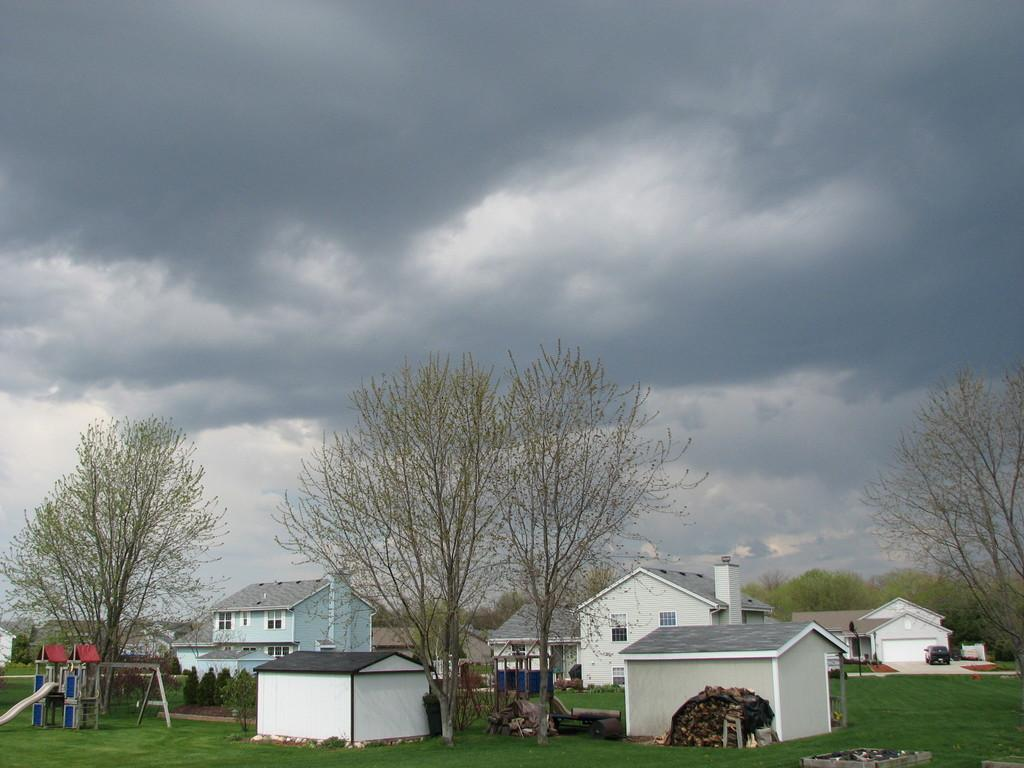What structures are located at the bottom of the image? There are houses at the bottom of the image. What type of vegetation is also present at the bottom of the image? There are trees at the bottom of the image. What is visible at the top of the image? The sky is visible at the top of the image. How many geese are flying in the distance in the image? There are no geese visible in the image. What type of whip is being used to create patterns in the sky? There is no whip present in the image, and no patterns are being created in the sky. 